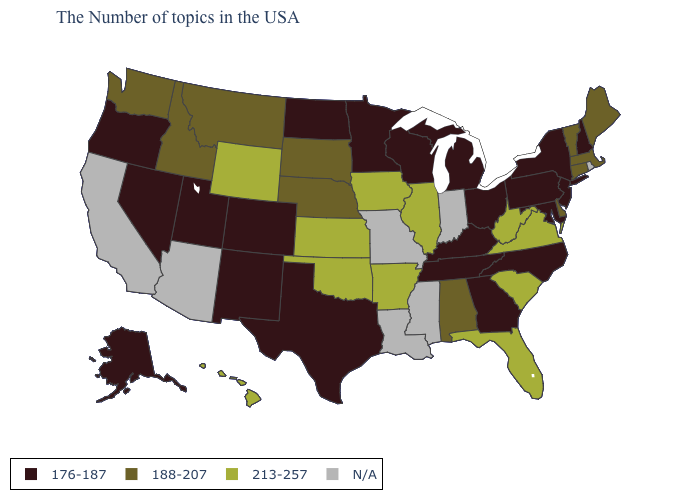Name the states that have a value in the range N/A?
Give a very brief answer. Rhode Island, Indiana, Mississippi, Louisiana, Missouri, Arizona, California. What is the value of Idaho?
Concise answer only. 188-207. What is the value of Oregon?
Give a very brief answer. 176-187. How many symbols are there in the legend?
Write a very short answer. 4. Does Hawaii have the highest value in the West?
Give a very brief answer. Yes. Name the states that have a value in the range N/A?
Give a very brief answer. Rhode Island, Indiana, Mississippi, Louisiana, Missouri, Arizona, California. What is the value of New Hampshire?
Concise answer only. 176-187. What is the value of Michigan?
Quick response, please. 176-187. Name the states that have a value in the range N/A?
Answer briefly. Rhode Island, Indiana, Mississippi, Louisiana, Missouri, Arizona, California. Among the states that border Nebraska , which have the highest value?
Answer briefly. Iowa, Kansas, Wyoming. What is the value of Nebraska?
Concise answer only. 188-207. Name the states that have a value in the range 213-257?
Keep it brief. Virginia, South Carolina, West Virginia, Florida, Illinois, Arkansas, Iowa, Kansas, Oklahoma, Wyoming, Hawaii. 